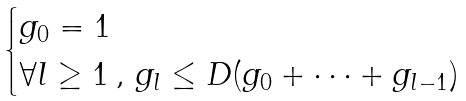Convert formula to latex. <formula><loc_0><loc_0><loc_500><loc_500>\begin{cases} g _ { 0 } = 1 \\ \forall l \geq 1 \, , \, g _ { l } \leq D ( g _ { 0 } + \cdots + g _ { l - 1 } ) \end{cases}</formula> 